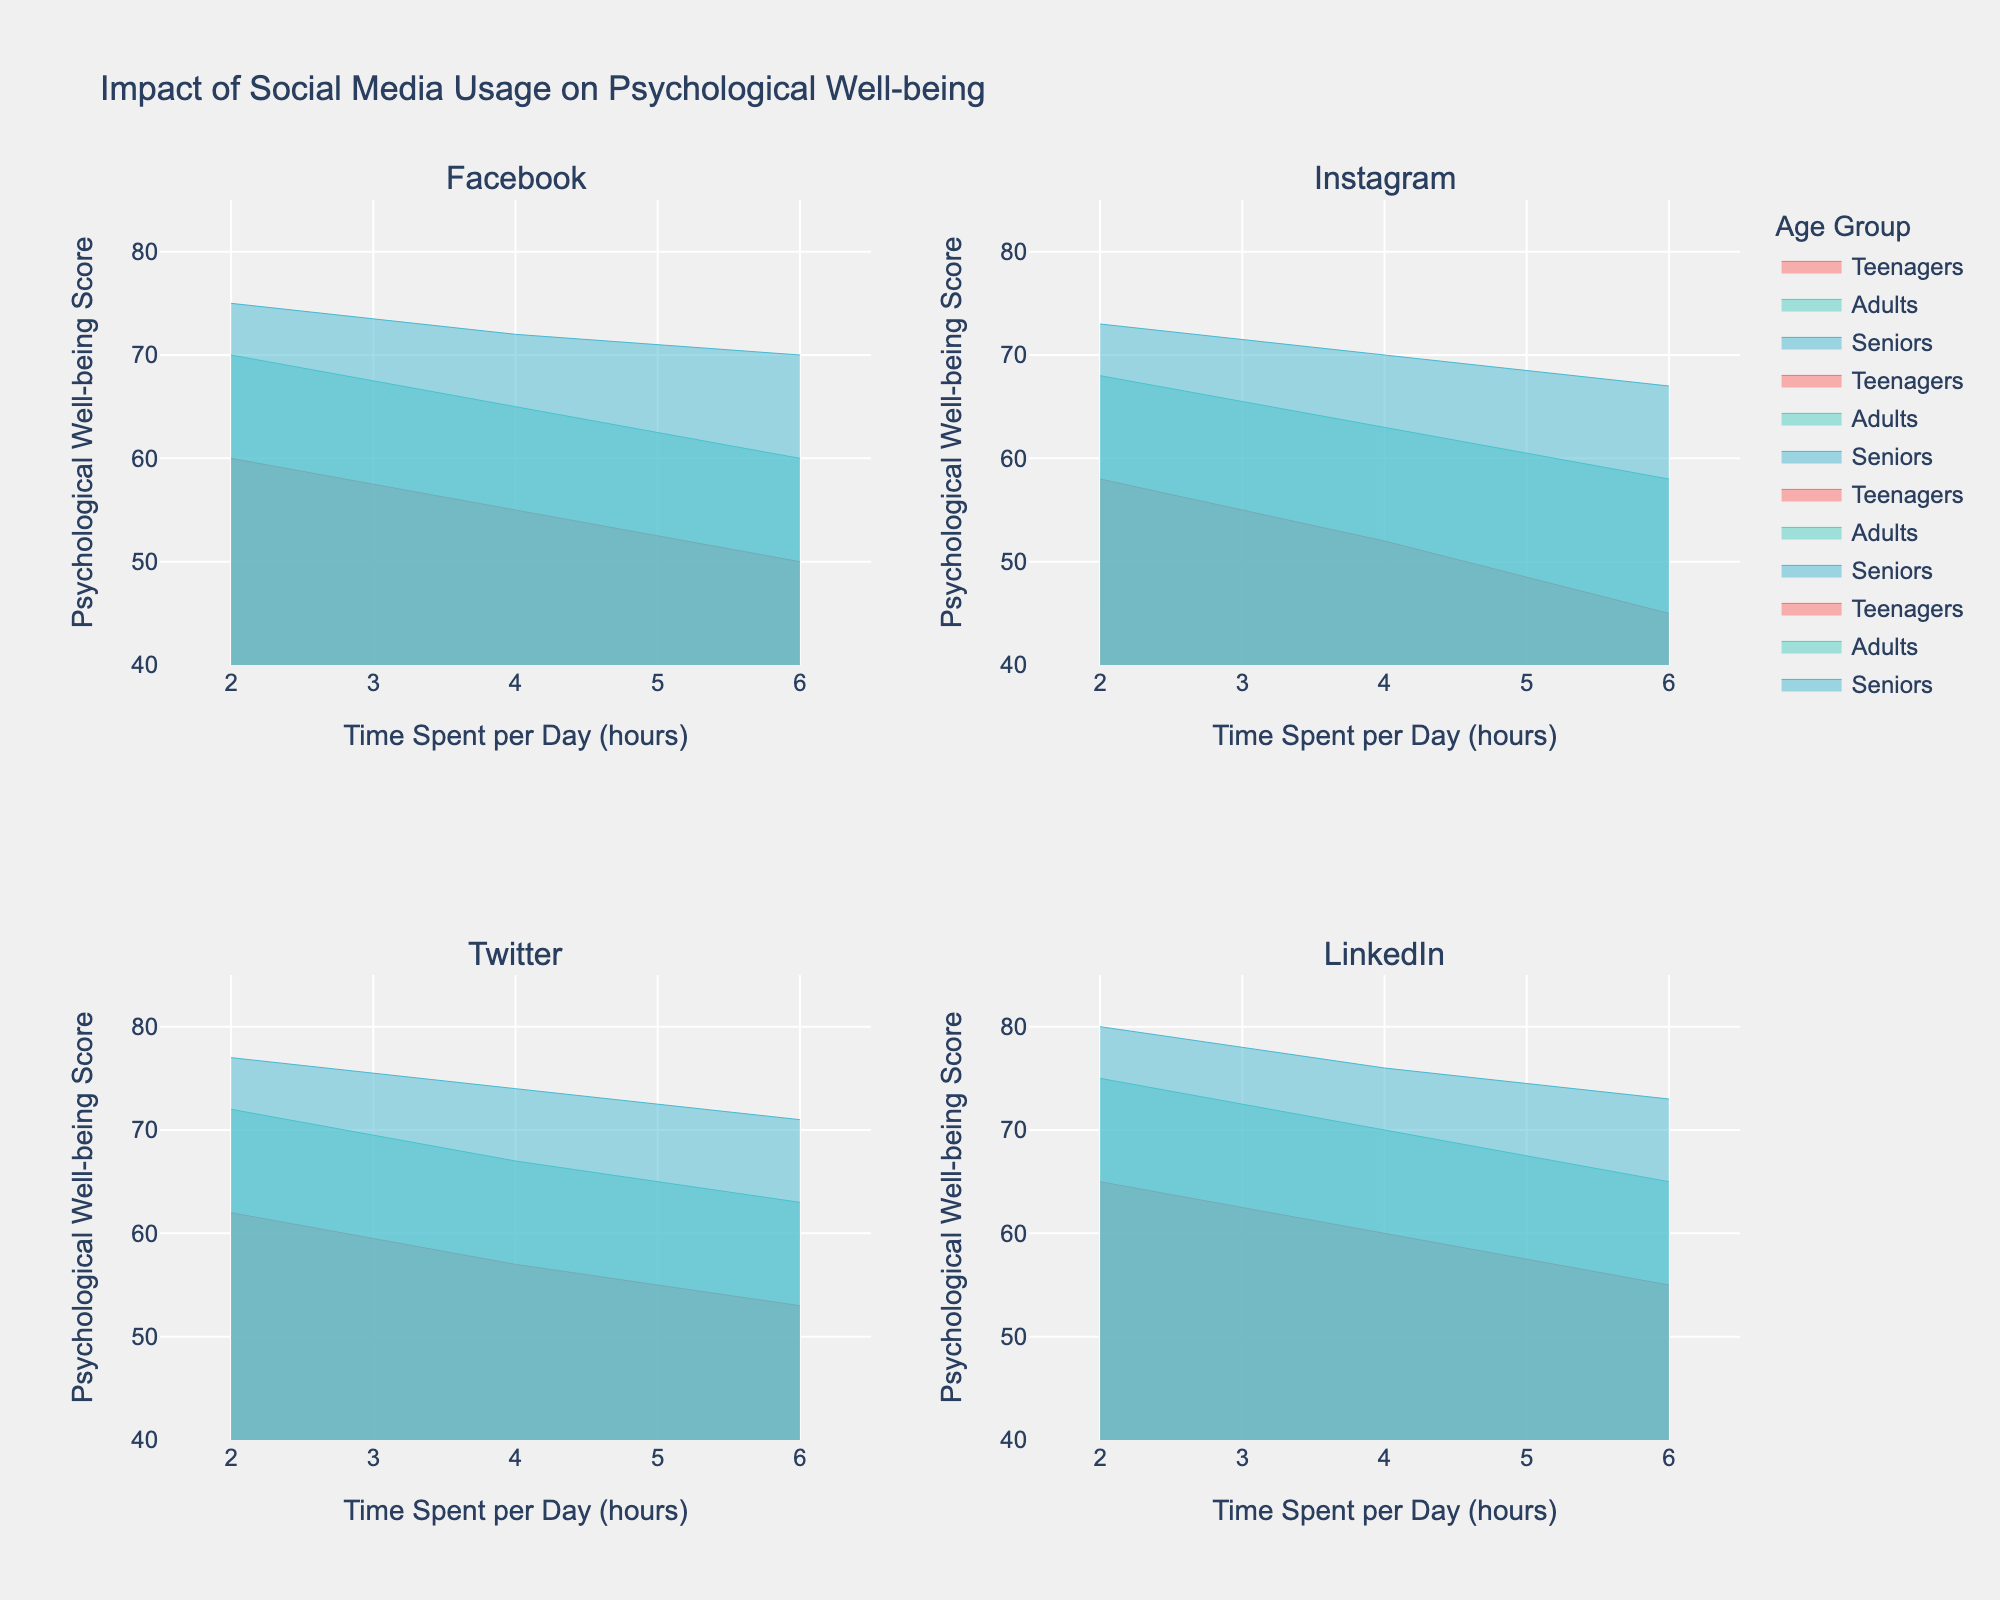What's the title of the figure? The title of the figure is typically found at the top. For this plot, it reads "Impact of Social Media Usage on Psychological Well-being."
Answer: Impact of Social Media Usage on Psychological Well-being Which age group has the highest Psychological Well-being Score for spending 2 hours per day on social media? To find this, look at the subplots for each platform and locate the markers at 2 hours spent per day. The highest score among all the age groups is on LinkedIn for Seniors (80).
Answer: Seniors (LinkedIn) What is the general trend of Psychological Well-being Scores as time spent on social media increases? Observe the direction in which the lines move as the x-axis values (time spent per day) increase for all subplots. The general trend across all age groups and platforms is a decrease in well-being scores as more time is spent on social media.
Answer: Decrease Which platform shows the least decline in Psychological Well-being Scores for Seniors from 2 to 6 hours per day? Compare the slopes of the lines for the Seniors' age group across each platform. LinkedIn shows the smallest decline from 80 to 73, which is a decrease of 7 points.
Answer: LinkedIn What is the difference in Psychological Well-being Scores for Teenagers using Instagram for 2 hours per day versus 4 hours per day? Locate the points for Teenagers on the Instagram subplot at 2 and 4 hours per day. The scores are 58 and 52, respectively. The difference is 58 - 52 = 6 points.
Answer: 6 points Which age group on Facebook shows the smallest change in well-being scores when comparing 2 and 4 hours of usage per day? On the Facebook subplot, compare the changes in scores between 2 and 4 hours for each age group. The Seniors' age group shows the smallest change from 75 to 72, a decrease of 3 points.
Answer: Seniors Is there any age group that shows an increase in Psychological Well-being Scores with an increase in time spent on social media? Review the lines on all subplots for any positive slopes. None of the age groups display an increase in well-being scores as the time spent on social media increases.
Answer: No Which age group has the highest range of Psychological Well-being Scores for Twitter? Review the difference between the highest and lowest points for each age group on the Twitter subplot. Seniors have the highest range from 77 to 71, which is a range of 6 points.
Answer: Seniors What is the average Psychological Well-being Score for Adults on LinkedIn across all time spent per day? Locate and sum the scores for Adults at 2, 4, and 6 hours on LinkedIn (75, 70, 65) and divide by 3. The average is (75+70+65)/3 = 70.
Answer: 70 For which platform does the Adult age group show the steepest decline in well-being scores from 4 to 6 hours per day? Examine the slopes between 4 and 6 hours for Adults on each platform. Instagram shows the steepest decline with scores dropping from 63 to 58, a decrease of 5 points.
Answer: Instagram 